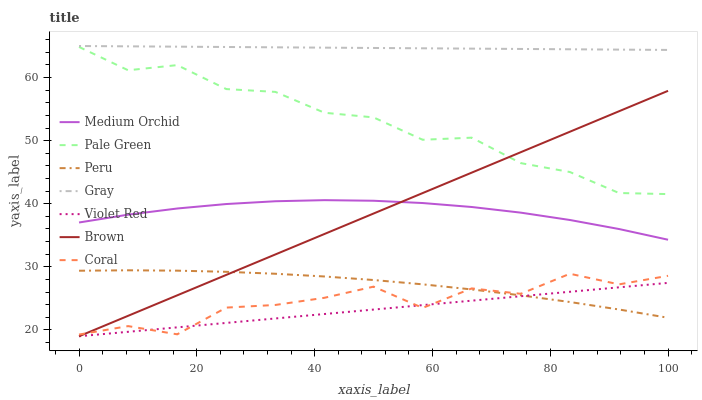Does Violet Red have the minimum area under the curve?
Answer yes or no. Yes. Does Gray have the maximum area under the curve?
Answer yes or no. Yes. Does Gray have the minimum area under the curve?
Answer yes or no. No. Does Violet Red have the maximum area under the curve?
Answer yes or no. No. Is Violet Red the smoothest?
Answer yes or no. Yes. Is Coral the roughest?
Answer yes or no. Yes. Is Gray the smoothest?
Answer yes or no. No. Is Gray the roughest?
Answer yes or no. No. Does Brown have the lowest value?
Answer yes or no. Yes. Does Gray have the lowest value?
Answer yes or no. No. Does Gray have the highest value?
Answer yes or no. Yes. Does Violet Red have the highest value?
Answer yes or no. No. Is Brown less than Gray?
Answer yes or no. Yes. Is Pale Green greater than Peru?
Answer yes or no. Yes. Does Peru intersect Brown?
Answer yes or no. Yes. Is Peru less than Brown?
Answer yes or no. No. Is Peru greater than Brown?
Answer yes or no. No. Does Brown intersect Gray?
Answer yes or no. No. 